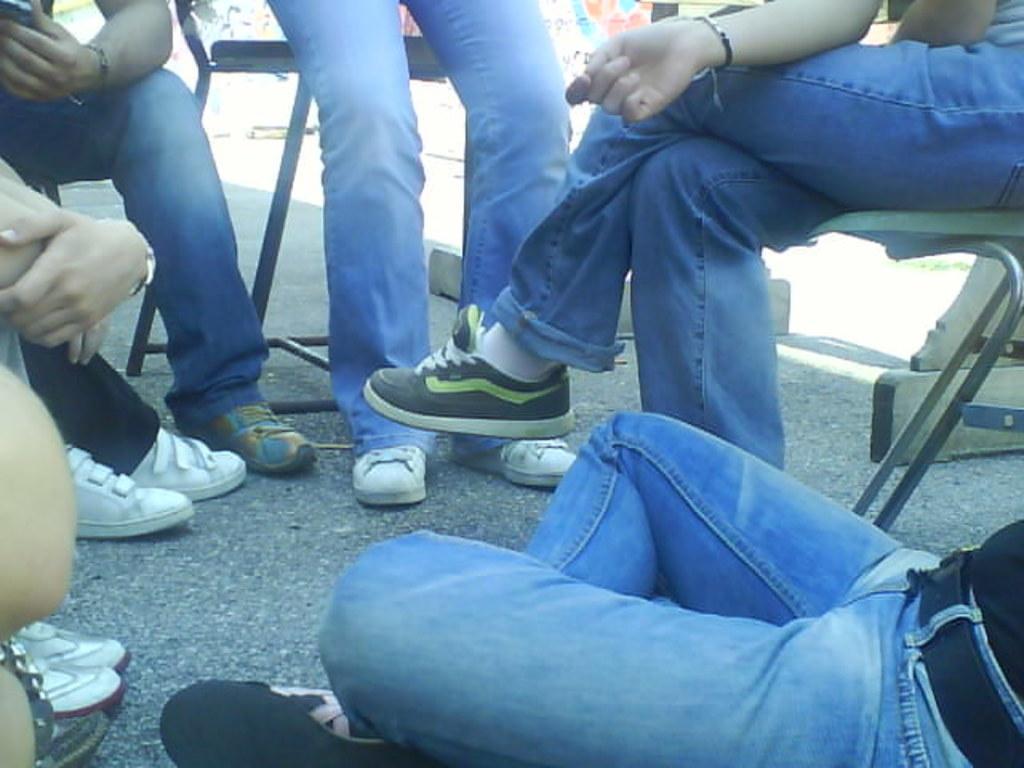In one or two sentences, can you explain what this image depicts? In this image we can see few person's legs wearing blue jeans and shoes, were among these two people are sitting on the road, these two people are sitting on the chairs and this person is standing on the road. In the background of the image we can see a wall. 